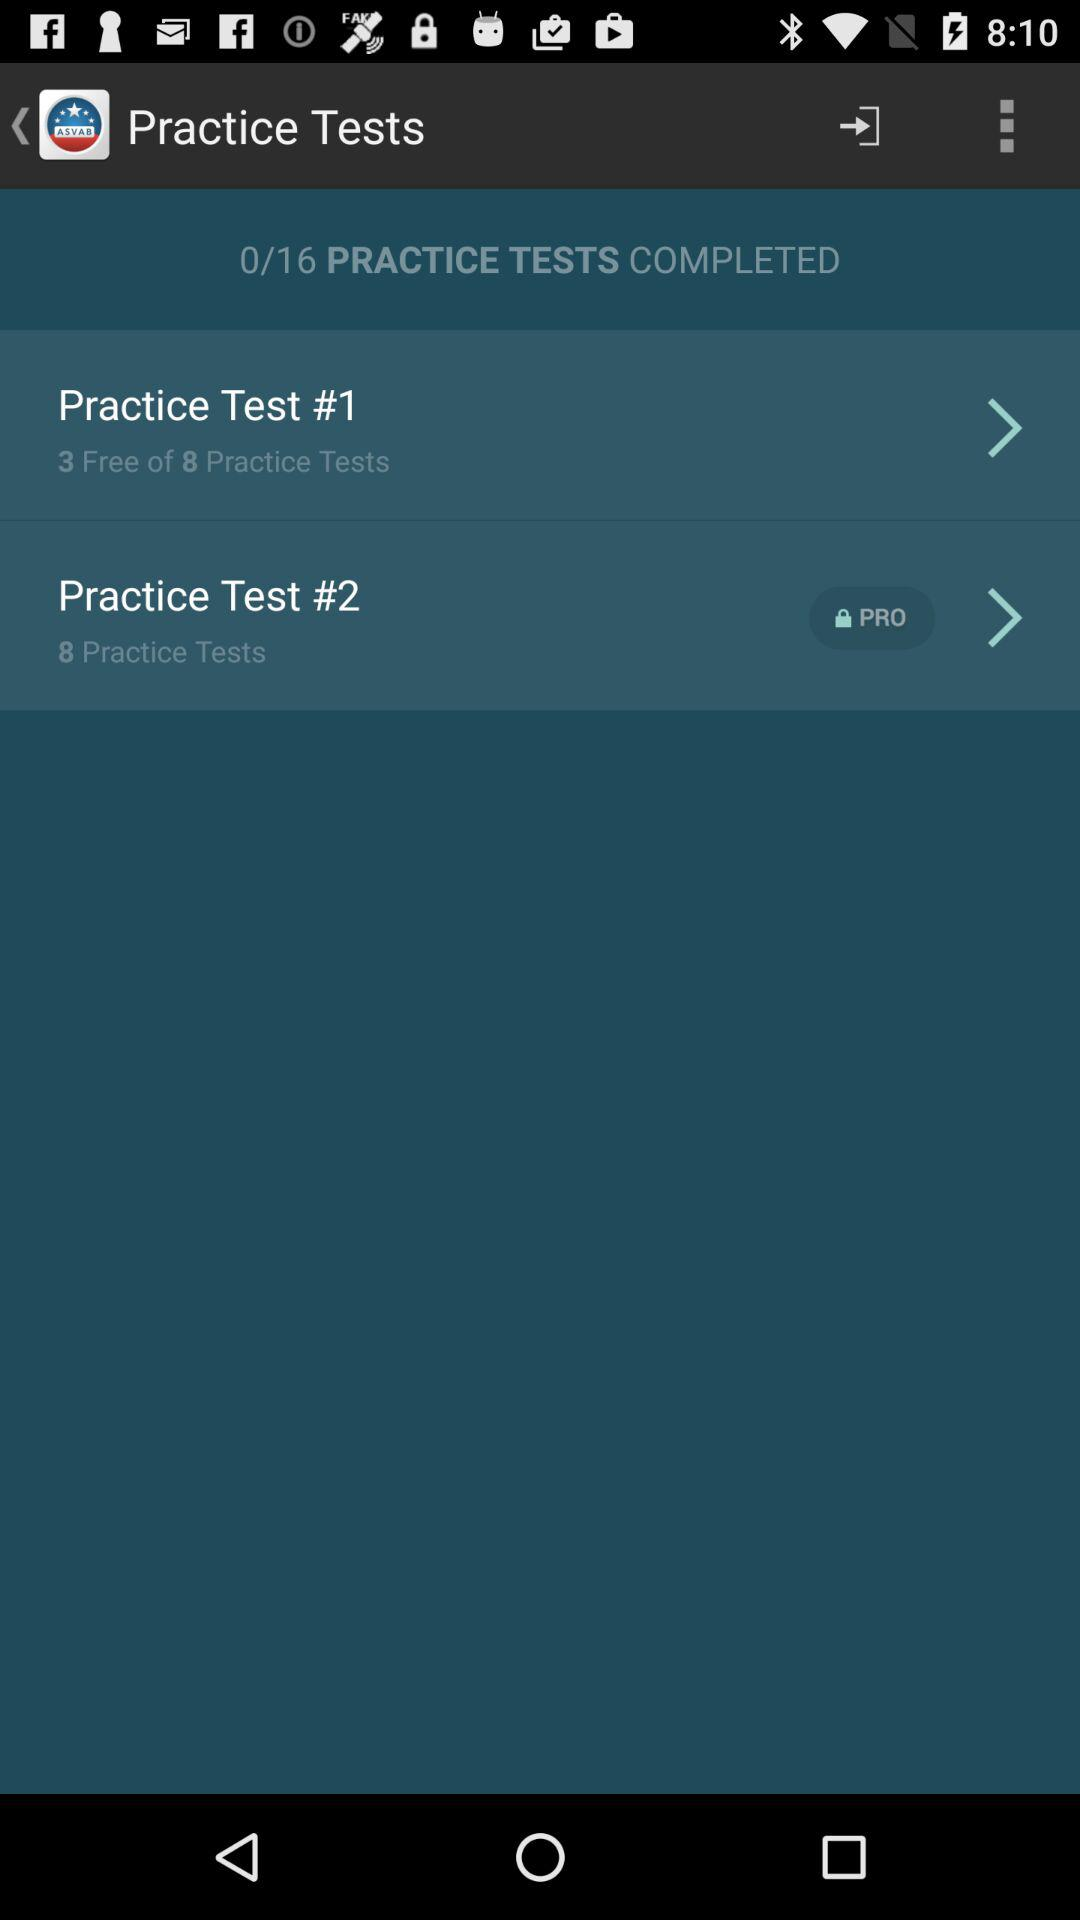How many practice tests are there in "Practice Test #2"? There are eight practice tests in "Practice Test #2". 